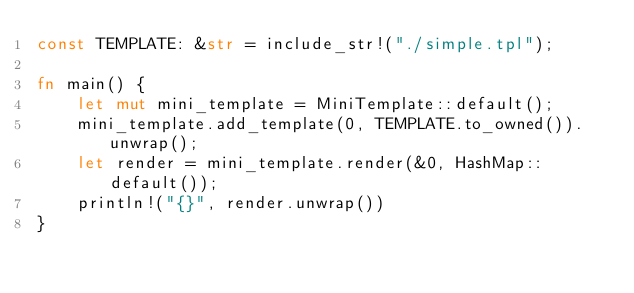Convert code to text. <code><loc_0><loc_0><loc_500><loc_500><_Rust_>const TEMPLATE: &str = include_str!("./simple.tpl");

fn main() {
    let mut mini_template = MiniTemplate::default();
    mini_template.add_template(0, TEMPLATE.to_owned()).unwrap();
    let render = mini_template.render(&0, HashMap::default());
    println!("{}", render.unwrap())
}
</code> 